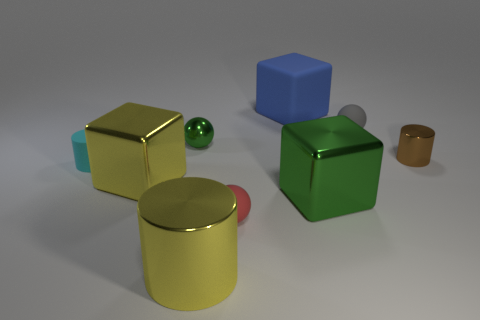Subtract 1 blocks. How many blocks are left? 2 Add 1 small matte objects. How many objects exist? 10 Subtract all spheres. How many objects are left? 6 Add 5 small brown shiny things. How many small brown shiny things exist? 6 Subtract 1 green spheres. How many objects are left? 8 Subtract all large green matte cubes. Subtract all large blue blocks. How many objects are left? 8 Add 7 brown things. How many brown things are left? 8 